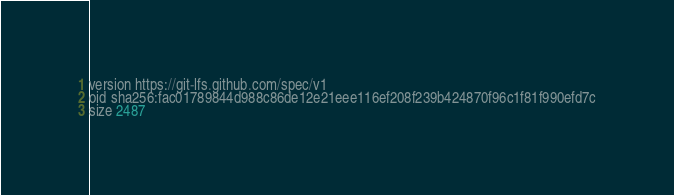Convert code to text. <code><loc_0><loc_0><loc_500><loc_500><_Python_>version https://git-lfs.github.com/spec/v1
oid sha256:fac01789844d988c86de12e21eee116ef208f239b424870f96c1f81f990efd7c
size 2487
</code> 